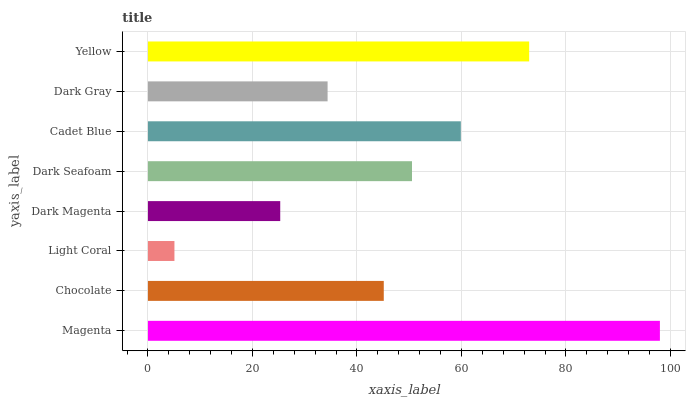Is Light Coral the minimum?
Answer yes or no. Yes. Is Magenta the maximum?
Answer yes or no. Yes. Is Chocolate the minimum?
Answer yes or no. No. Is Chocolate the maximum?
Answer yes or no. No. Is Magenta greater than Chocolate?
Answer yes or no. Yes. Is Chocolate less than Magenta?
Answer yes or no. Yes. Is Chocolate greater than Magenta?
Answer yes or no. No. Is Magenta less than Chocolate?
Answer yes or no. No. Is Dark Seafoam the high median?
Answer yes or no. Yes. Is Chocolate the low median?
Answer yes or no. Yes. Is Chocolate the high median?
Answer yes or no. No. Is Light Coral the low median?
Answer yes or no. No. 